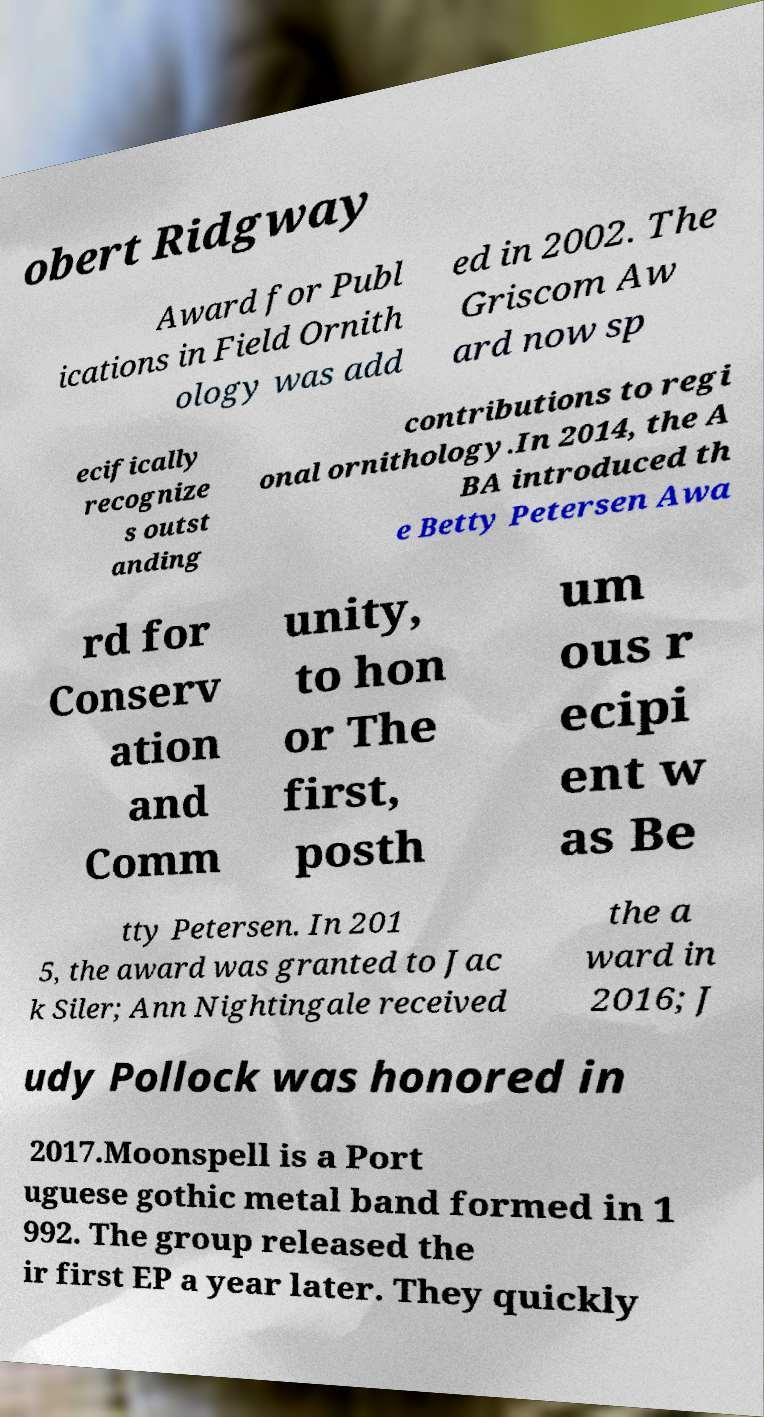Can you accurately transcribe the text from the provided image for me? obert Ridgway Award for Publ ications in Field Ornith ology was add ed in 2002. The Griscom Aw ard now sp ecifically recognize s outst anding contributions to regi onal ornithology.In 2014, the A BA introduced th e Betty Petersen Awa rd for Conserv ation and Comm unity, to hon or The first, posth um ous r ecipi ent w as Be tty Petersen. In 201 5, the award was granted to Jac k Siler; Ann Nightingale received the a ward in 2016; J udy Pollock was honored in 2017.Moonspell is a Port uguese gothic metal band formed in 1 992. The group released the ir first EP a year later. They quickly 